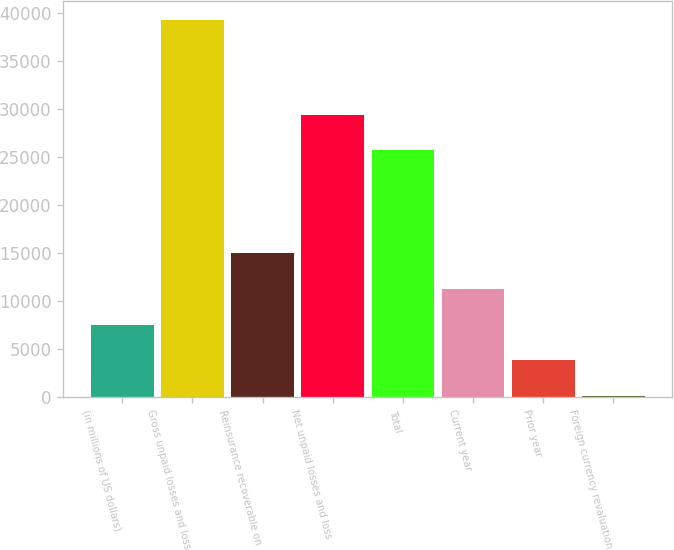<chart> <loc_0><loc_0><loc_500><loc_500><bar_chart><fcel>(in millions of US dollars)<fcel>Gross unpaid losses and loss<fcel>Reinsurance recoverable on<fcel>Net unpaid losses and loss<fcel>Total<fcel>Current year<fcel>Prior year<fcel>Foreign currency revaluation<nl><fcel>7556<fcel>39211.5<fcel>14945<fcel>29397<fcel>25702.5<fcel>11250.5<fcel>3861.5<fcel>167<nl></chart> 